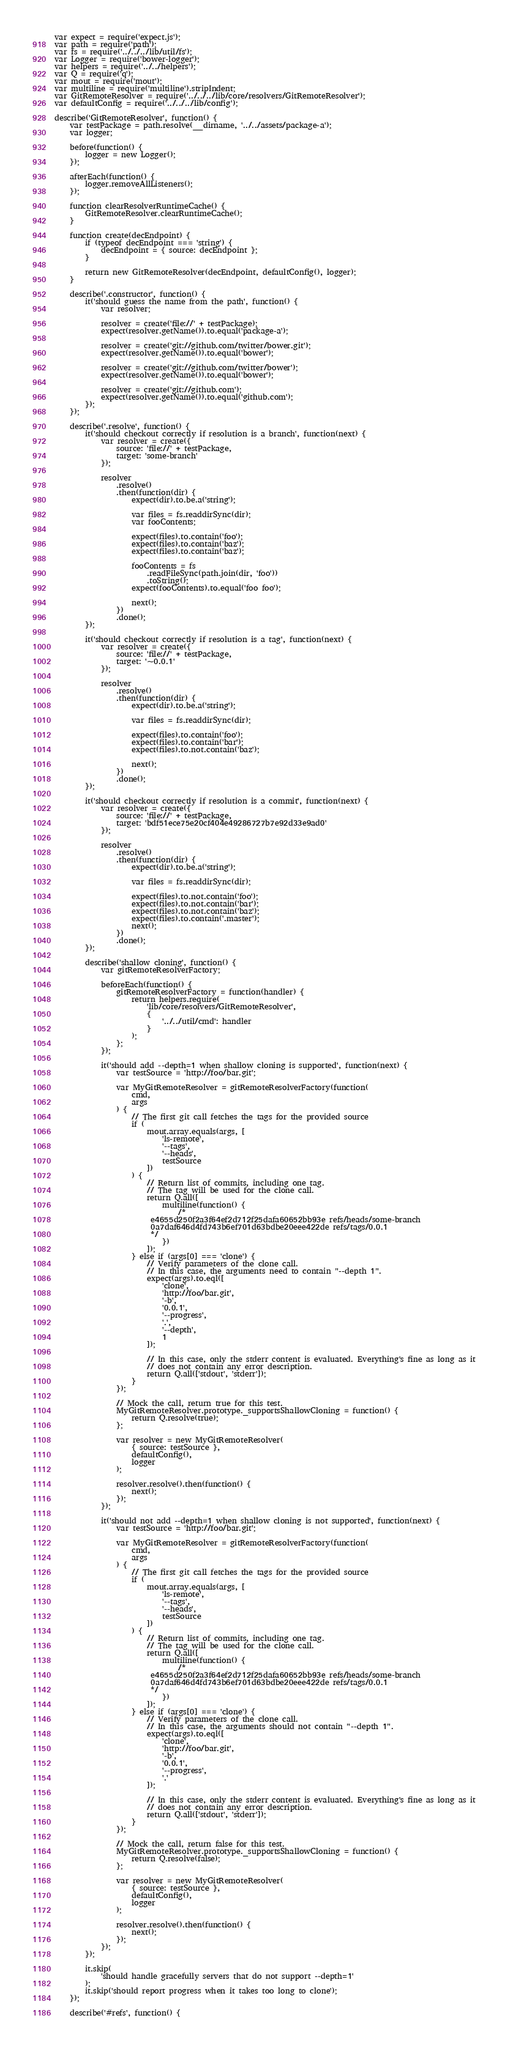Convert code to text. <code><loc_0><loc_0><loc_500><loc_500><_JavaScript_>var expect = require('expect.js');
var path = require('path');
var fs = require('../../../lib/util/fs');
var Logger = require('bower-logger');
var helpers = require('../../helpers');
var Q = require('q');
var mout = require('mout');
var multiline = require('multiline').stripIndent;
var GitRemoteResolver = require('../../../lib/core/resolvers/GitRemoteResolver');
var defaultConfig = require('../../../lib/config');

describe('GitRemoteResolver', function() {
    var testPackage = path.resolve(__dirname, '../../assets/package-a');
    var logger;

    before(function() {
        logger = new Logger();
    });

    afterEach(function() {
        logger.removeAllListeners();
    });

    function clearResolverRuntimeCache() {
        GitRemoteResolver.clearRuntimeCache();
    }

    function create(decEndpoint) {
        if (typeof decEndpoint === 'string') {
            decEndpoint = { source: decEndpoint };
        }

        return new GitRemoteResolver(decEndpoint, defaultConfig(), logger);
    }

    describe('.constructor', function() {
        it('should guess the name from the path', function() {
            var resolver;

            resolver = create('file://' + testPackage);
            expect(resolver.getName()).to.equal('package-a');

            resolver = create('git://github.com/twitter/bower.git');
            expect(resolver.getName()).to.equal('bower');

            resolver = create('git://github.com/twitter/bower');
            expect(resolver.getName()).to.equal('bower');

            resolver = create('git://github.com');
            expect(resolver.getName()).to.equal('github.com');
        });
    });

    describe('.resolve', function() {
        it('should checkout correctly if resolution is a branch', function(next) {
            var resolver = create({
                source: 'file://' + testPackage,
                target: 'some-branch'
            });

            resolver
                .resolve()
                .then(function(dir) {
                    expect(dir).to.be.a('string');

                    var files = fs.readdirSync(dir);
                    var fooContents;

                    expect(files).to.contain('foo');
                    expect(files).to.contain('baz');
                    expect(files).to.contain('baz');

                    fooContents = fs
                        .readFileSync(path.join(dir, 'foo'))
                        .toString();
                    expect(fooContents).to.equal('foo foo');

                    next();
                })
                .done();
        });

        it('should checkout correctly if resolution is a tag', function(next) {
            var resolver = create({
                source: 'file://' + testPackage,
                target: '~0.0.1'
            });

            resolver
                .resolve()
                .then(function(dir) {
                    expect(dir).to.be.a('string');

                    var files = fs.readdirSync(dir);

                    expect(files).to.contain('foo');
                    expect(files).to.contain('bar');
                    expect(files).to.not.contain('baz');

                    next();
                })
                .done();
        });

        it('should checkout correctly if resolution is a commit', function(next) {
            var resolver = create({
                source: 'file://' + testPackage,
                target: 'bdf51ece75e20cf404e49286727b7e92d33e9ad0'
            });

            resolver
                .resolve()
                .then(function(dir) {
                    expect(dir).to.be.a('string');

                    var files = fs.readdirSync(dir);

                    expect(files).to.not.contain('foo');
                    expect(files).to.not.contain('bar');
                    expect(files).to.not.contain('baz');
                    expect(files).to.contain('.master');
                    next();
                })
                .done();
        });

        describe('shallow cloning', function() {
            var gitRemoteResolverFactory;

            beforeEach(function() {
                gitRemoteResolverFactory = function(handler) {
                    return helpers.require(
                        'lib/core/resolvers/GitRemoteResolver',
                        {
                            '../../util/cmd': handler
                        }
                    );
                };
            });

            it('should add --depth=1 when shallow cloning is supported', function(next) {
                var testSource = 'http://foo/bar.git';

                var MyGitRemoteResolver = gitRemoteResolverFactory(function(
                    cmd,
                    args
                ) {
                    // The first git call fetches the tags for the provided source
                    if (
                        mout.array.equals(args, [
                            'ls-remote',
                            '--tags',
                            '--heads',
                            testSource
                        ])
                    ) {
                        // Return list of commits, including one tag.
                        // The tag will be used for the clone call.
                        return Q.all([
                            multiline(function() {
                                /*
                         e4655d250f2a3f64ef2d712f25dafa60652bb93e refs/heads/some-branch
                         0a7daf646d4fd743b6ef701d63bdbe20eee422de refs/tags/0.0.1
                         */
                            })
                        ]);
                    } else if (args[0] === 'clone') {
                        // Verify parameters of the clone call.
                        // In this case, the arguments need to contain "--depth 1".
                        expect(args).to.eql([
                            'clone',
                            'http://foo/bar.git',
                            '-b',
                            '0.0.1',
                            '--progress',
                            '.',
                            '--depth',
                            1
                        ]);

                        // In this case, only the stderr content is evaluated. Everything's fine as long as it
                        // does not contain any error description.
                        return Q.all(['stdout', 'stderr']);
                    }
                });

                // Mock the call, return true for this test.
                MyGitRemoteResolver.prototype._supportsShallowCloning = function() {
                    return Q.resolve(true);
                };

                var resolver = new MyGitRemoteResolver(
                    { source: testSource },
                    defaultConfig(),
                    logger
                );

                resolver.resolve().then(function() {
                    next();
                });
            });

            it('should not add --depth=1 when shallow cloning is not supported', function(next) {
                var testSource = 'http://foo/bar.git';

                var MyGitRemoteResolver = gitRemoteResolverFactory(function(
                    cmd,
                    args
                ) {
                    // The first git call fetches the tags for the provided source
                    if (
                        mout.array.equals(args, [
                            'ls-remote',
                            '--tags',
                            '--heads',
                            testSource
                        ])
                    ) {
                        // Return list of commits, including one tag.
                        // The tag will be used for the clone call.
                        return Q.all([
                            multiline(function() {
                                /*
                         e4655d250f2a3f64ef2d712f25dafa60652bb93e refs/heads/some-branch
                         0a7daf646d4fd743b6ef701d63bdbe20eee422de refs/tags/0.0.1
                         */
                            })
                        ]);
                    } else if (args[0] === 'clone') {
                        // Verify parameters of the clone call.
                        // In this case, the arguments should not contain "--depth 1".
                        expect(args).to.eql([
                            'clone',
                            'http://foo/bar.git',
                            '-b',
                            '0.0.1',
                            '--progress',
                            '.'
                        ]);

                        // In this case, only the stderr content is evaluated. Everything's fine as long as it
                        // does not contain any error description.
                        return Q.all(['stdout', 'stderr']);
                    }
                });

                // Mock the call, return false for this test.
                MyGitRemoteResolver.prototype._supportsShallowCloning = function() {
                    return Q.resolve(false);
                };

                var resolver = new MyGitRemoteResolver(
                    { source: testSource },
                    defaultConfig(),
                    logger
                );

                resolver.resolve().then(function() {
                    next();
                });
            });
        });

        it.skip(
            'should handle gracefully servers that do not support --depth=1'
        );
        it.skip('should report progress when it takes too long to clone');
    });

    describe('#refs', function() {</code> 